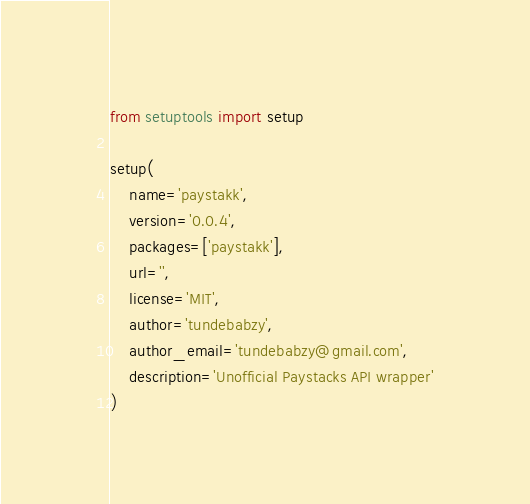<code> <loc_0><loc_0><loc_500><loc_500><_Python_>from setuptools import setup

setup(
	name='paystakk',
	version='0.0.4',
	packages=['paystakk'],
	url='',
	license='MIT',
	author='tundebabzy',
	author_email='tundebabzy@gmail.com',
	description='Unofficial Paystacks API wrapper'
)
</code> 